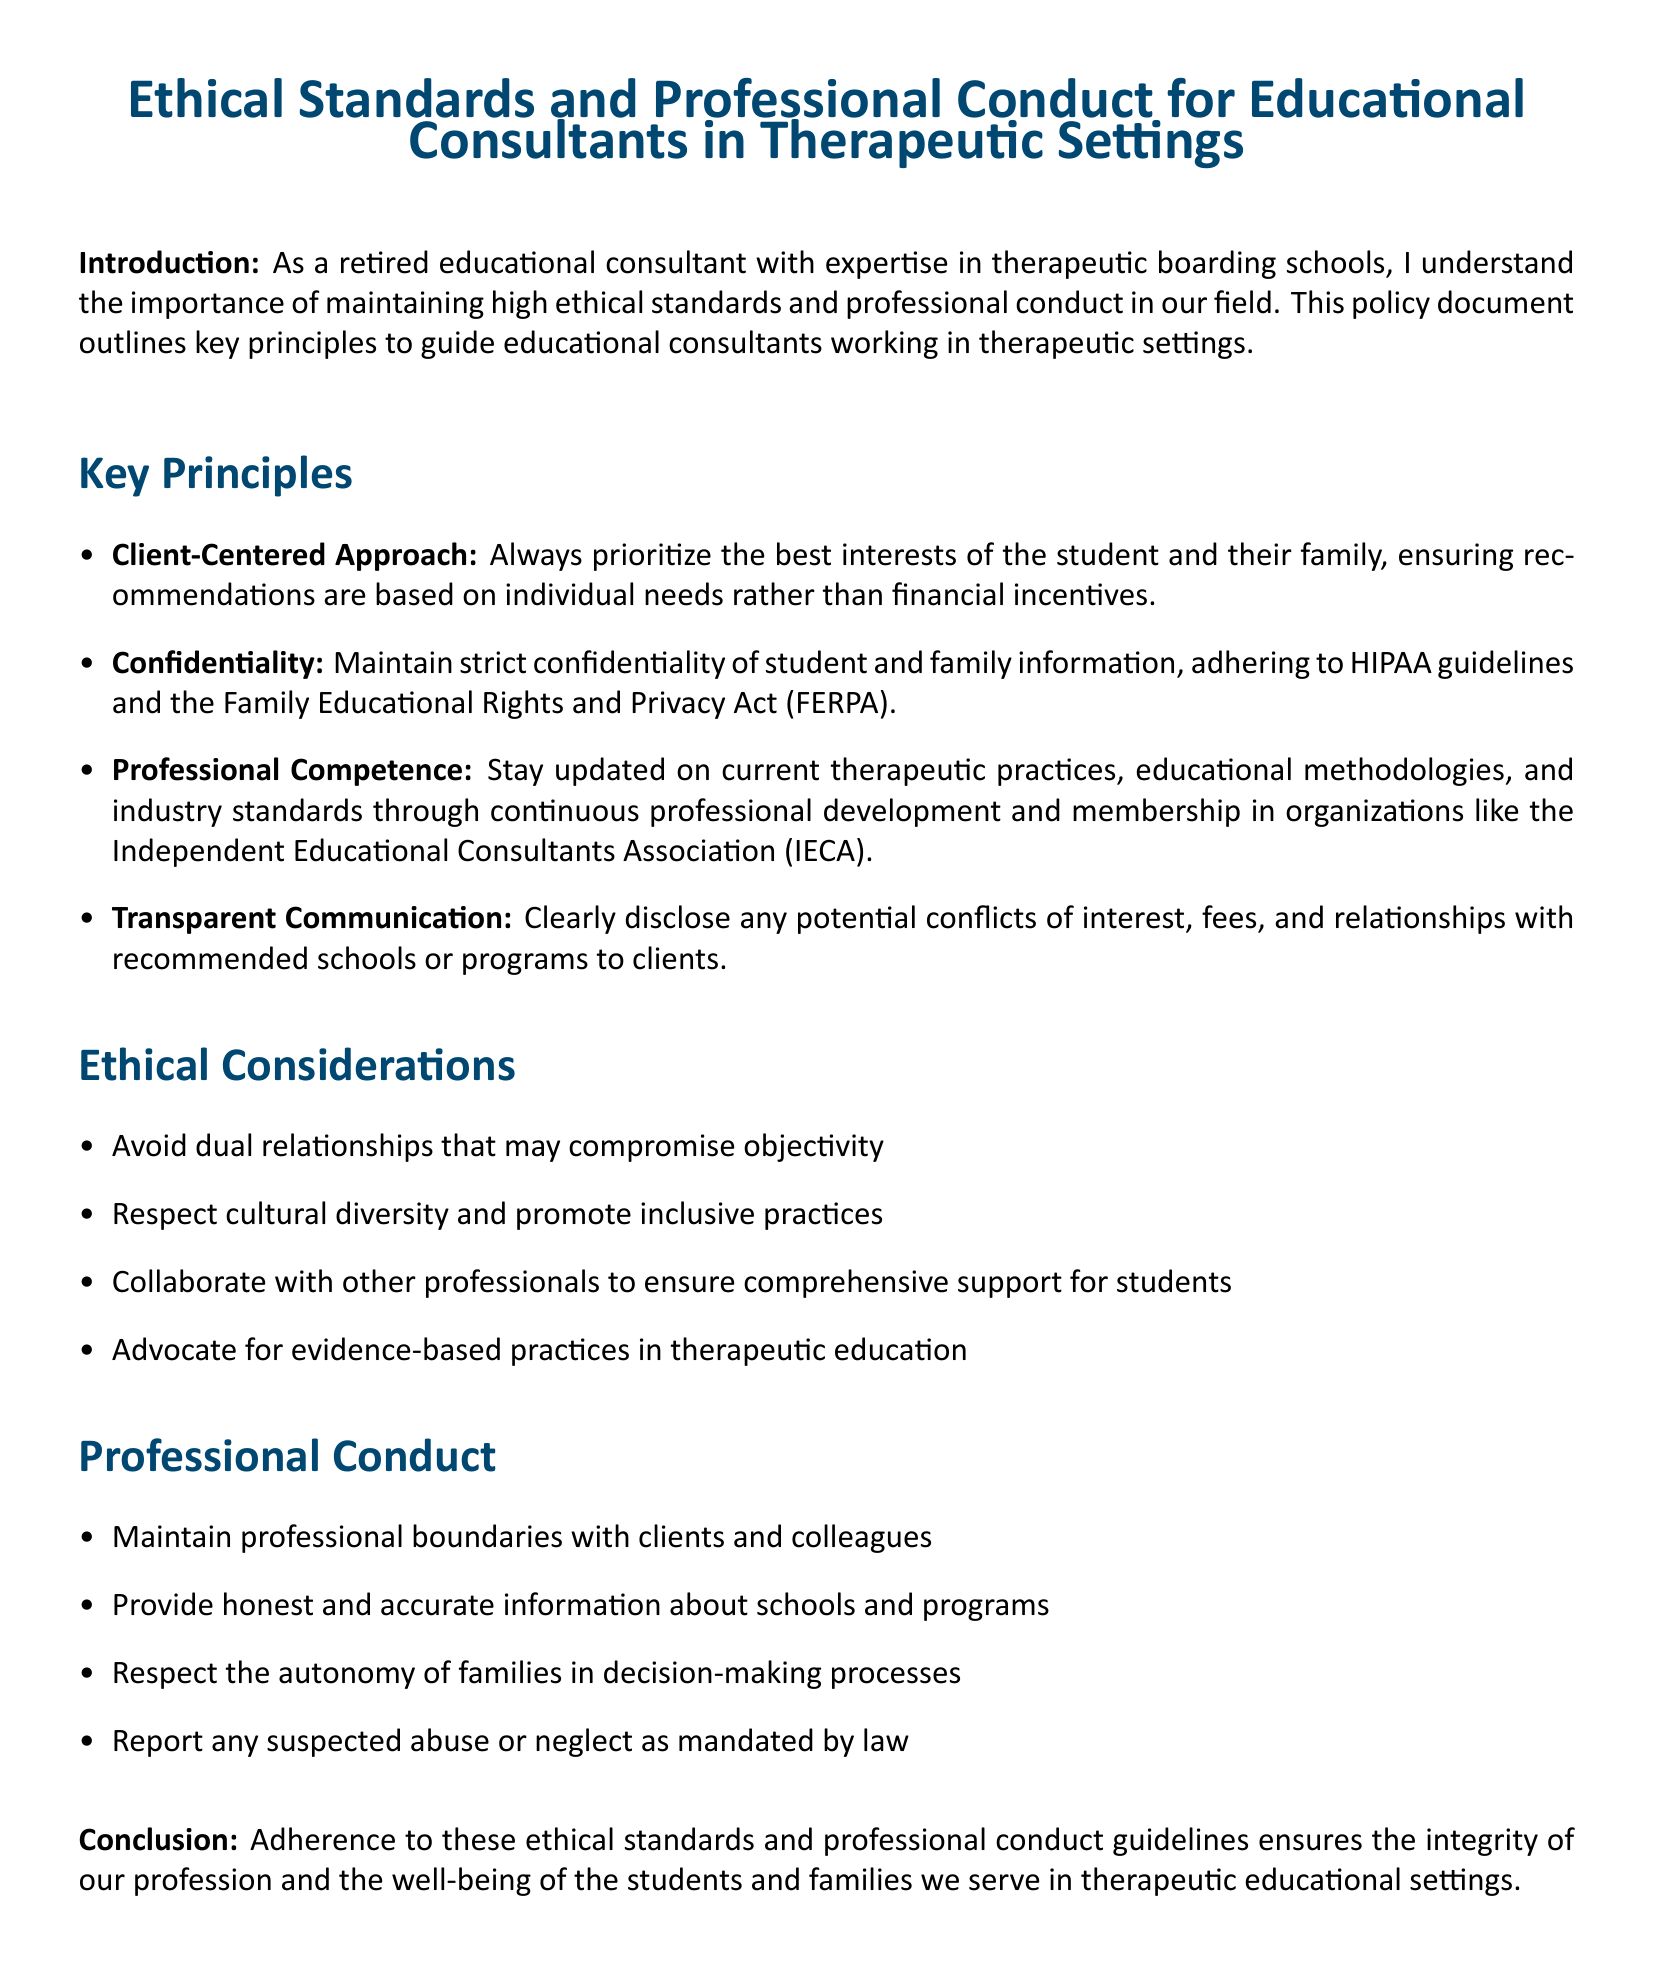What is the title of the document? The title of the document is listed at the beginning of the document.
Answer: Ethical Standards and Professional Conduct for Educational Consultants in Therapeutic Settings What does the client-centered approach prioritize? The document specifies the focus of the client-centered approach in the key principles section.
Answer: Best interests of the student and their family What is one ethical consideration mentioned? The document lists several ethical considerations directly under the relevant section.
Answer: Avoid dual relationships What type of communication is emphasized in the key principles? The document highlights the importance of communication in the key principles section.
Answer: Transparent Communication What organization is recommended for membership to stay updated? The document suggests membership in an organization for continuous professional development.
Answer: Independent Educational Consultants Association (IECA) What must be reported by educational consultants according to professional conduct? This is outlined under the professional conduct section of the document.
Answer: Suspected abuse or neglect How should educational consultants maintain relationships with clients? This query seeks information from the professional conduct section.
Answer: Maintain professional boundaries What legal guidelines must be adhered to regarding confidentiality? The document mentions specific regulations under the confidentiality principle.
Answer: HIPAA and FERPA What is the main purpose of adhering to these ethical standards? The document concludes with the purpose statement related to ethical standards.
Answer: Integrity of our profession and well-being of students and families 